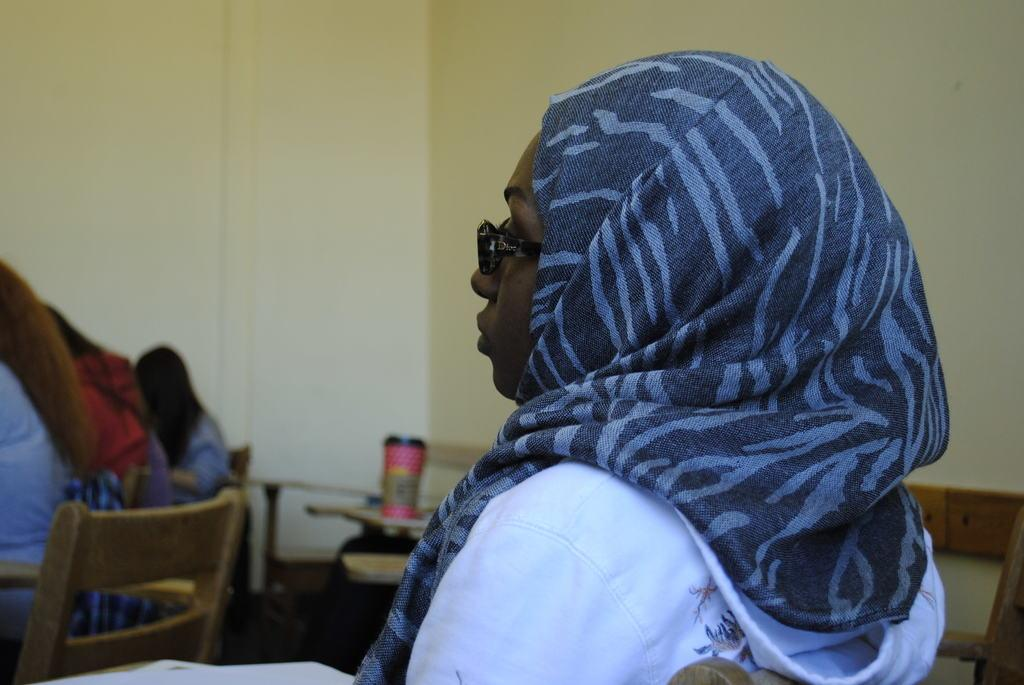Who is the main subject in the foreground of the image? There is a lady in the foreground of the image. What is the lady doing in the image? The lady is sitting. What accessories is the lady wearing in the image? The lady is wearing a scarf and glasses. Can you describe the people sitting in front of the lady? There are other people sitting in front of the lady. What can be seen in the background of the image? There is a wall in the background of the image. What type of pear can be seen hanging from the scarf in the image? There is no pear present in the image, nor is it hanging from the lady's scarf. 